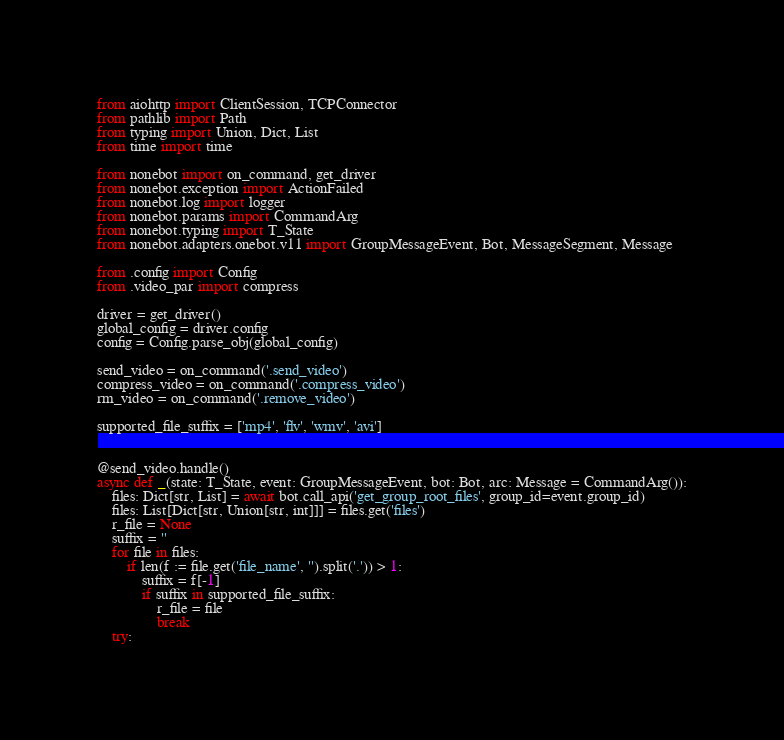<code> <loc_0><loc_0><loc_500><loc_500><_Python_>from aiohttp import ClientSession, TCPConnector
from pathlib import Path
from typing import Union, Dict, List
from time import time

from nonebot import on_command, get_driver
from nonebot.exception import ActionFailed
from nonebot.log import logger
from nonebot.params import CommandArg
from nonebot.typing import T_State
from nonebot.adapters.onebot.v11 import GroupMessageEvent, Bot, MessageSegment, Message

from .config import Config
from .video_par import compress

driver = get_driver()
global_config = driver.config
config = Config.parse_obj(global_config)

send_video = on_command('.send_video')
compress_video = on_command('.compress_video')
rm_video = on_command('.remove_video')

supported_file_suffix = ['mp4', 'flv', 'wmv', 'avi']


@send_video.handle()
async def _(state: T_State, event: GroupMessageEvent, bot: Bot, arc: Message = CommandArg()):
    files: Dict[str, List] = await bot.call_api('get_group_root_files', group_id=event.group_id)
    files: List[Dict[str, Union[str, int]]] = files.get('files')
    r_file = None
    suffix = ''
    for file in files:
        if len(f := file.get('file_name', '').split('.')) > 1:
            suffix = f[-1]
            if suffix in supported_file_suffix:
                r_file = file
                break
    try:</code> 